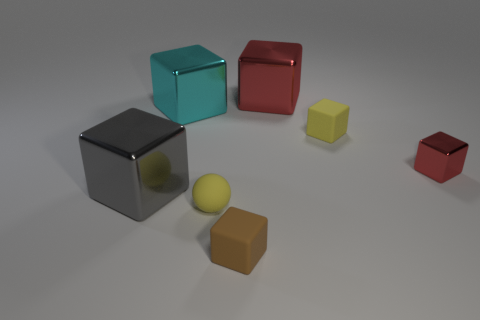What number of other things are the same size as the cyan cube?
Provide a short and direct response. 2. How many small rubber things are behind the tiny brown matte cube?
Give a very brief answer. 2. The brown rubber cube has what size?
Make the answer very short. Small. Is the material of the small cube that is in front of the matte sphere the same as the yellow thing that is on the right side of the big red metal block?
Your answer should be very brief. Yes. Is there a matte thing that has the same color as the rubber sphere?
Your answer should be compact. Yes. The ball that is the same size as the brown matte object is what color?
Keep it short and to the point. Yellow. Does the big object on the right side of the tiny yellow ball have the same color as the small metal block?
Make the answer very short. Yes. Are there any red objects made of the same material as the gray cube?
Your answer should be compact. Yes. What is the shape of the thing that is the same color as the rubber sphere?
Your answer should be compact. Cube. Is the number of large gray metallic blocks behind the large red block less than the number of brown rubber blocks?
Give a very brief answer. Yes. 